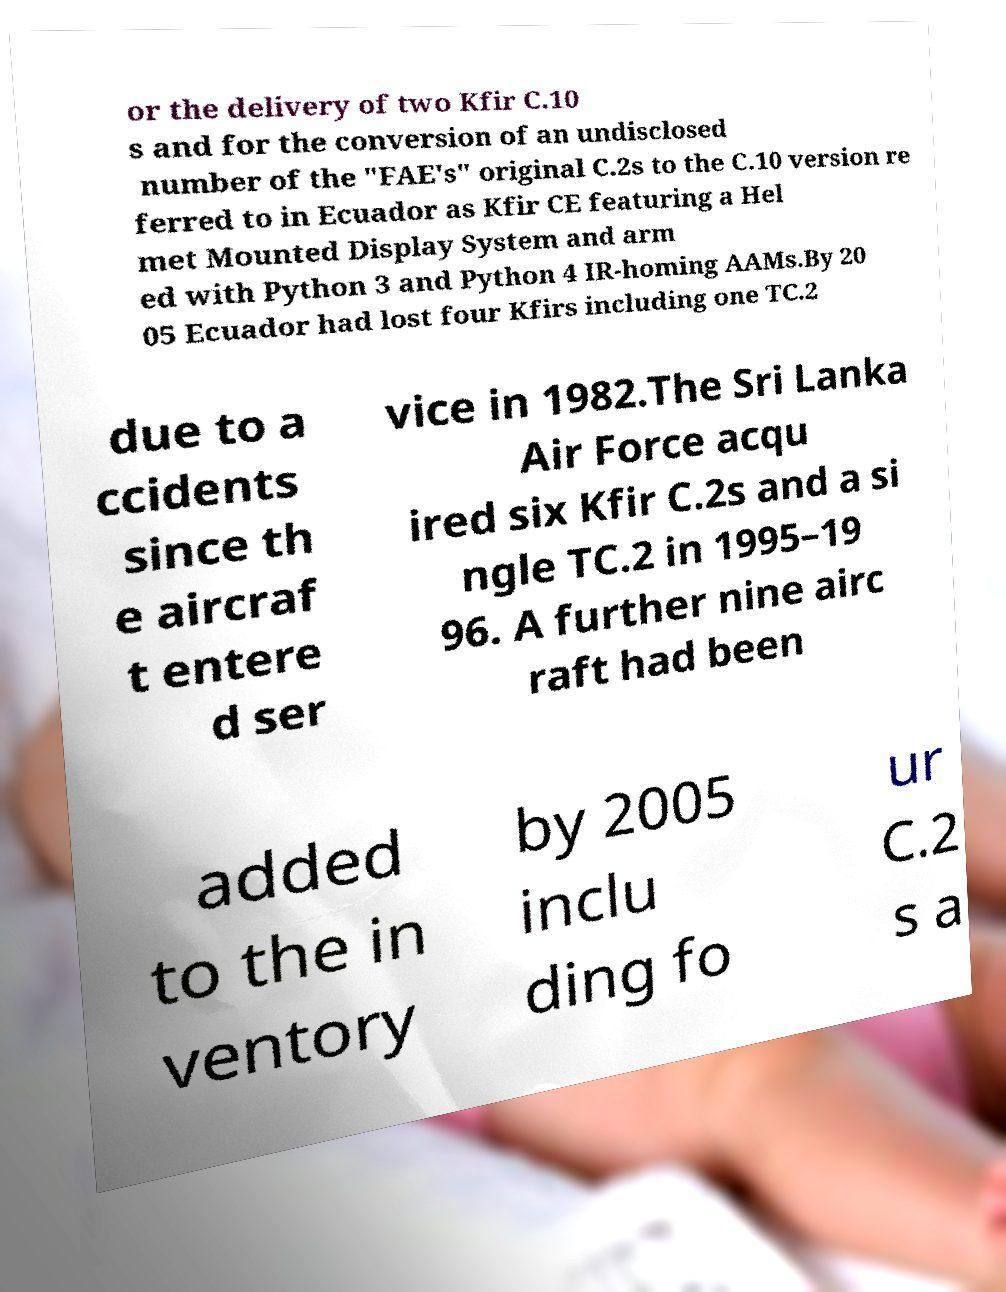For documentation purposes, I need the text within this image transcribed. Could you provide that? or the delivery of two Kfir C.10 s and for the conversion of an undisclosed number of the "FAE's" original C.2s to the C.10 version re ferred to in Ecuador as Kfir CE featuring a Hel met Mounted Display System and arm ed with Python 3 and Python 4 IR-homing AAMs.By 20 05 Ecuador had lost four Kfirs including one TC.2 due to a ccidents since th e aircraf t entere d ser vice in 1982.The Sri Lanka Air Force acqu ired six Kfir C.2s and a si ngle TC.2 in 1995–19 96. A further nine airc raft had been added to the in ventory by 2005 inclu ding fo ur C.2 s a 